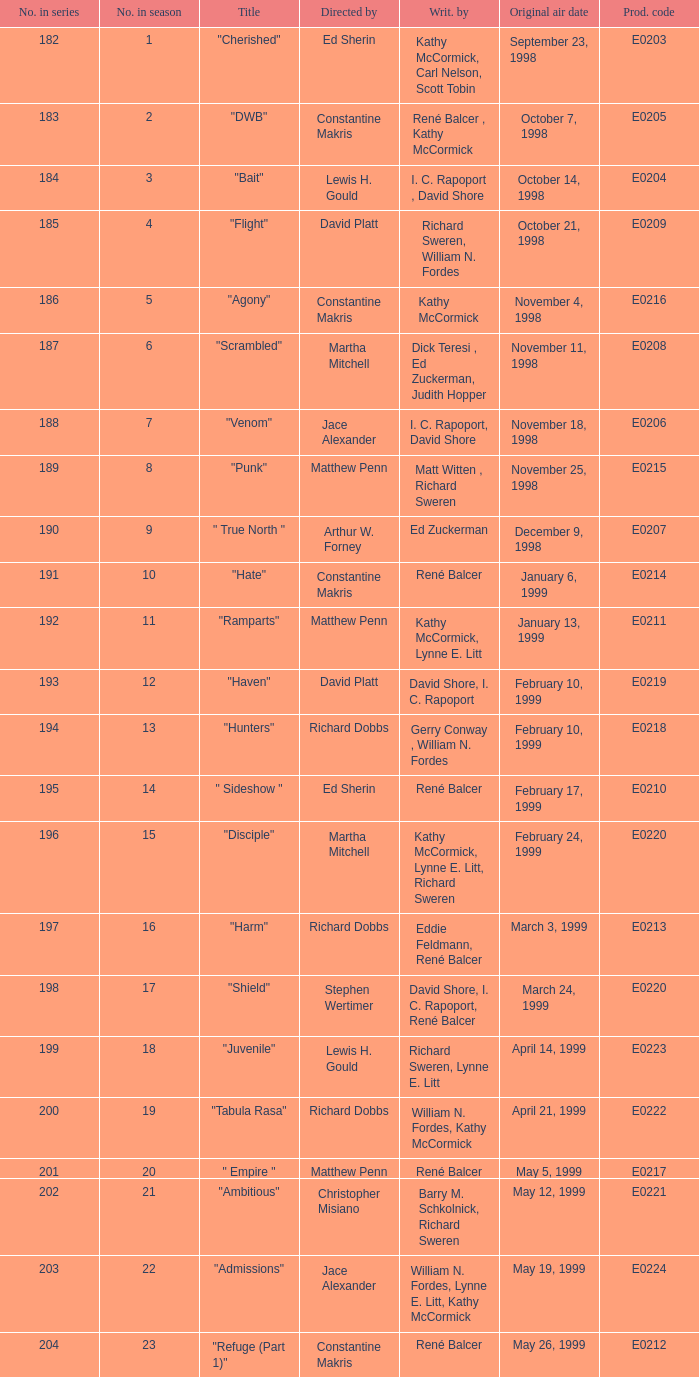The episode with the title "Bait" has what original air date? October 14, 1998. 